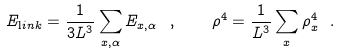Convert formula to latex. <formula><loc_0><loc_0><loc_500><loc_500>E _ { \mathrm l i n k } = \frac { 1 } { 3 L ^ { 3 } } \sum _ { x , \alpha } E _ { x , \alpha } \ , \quad \rho ^ { 4 } = \frac { 1 } { L ^ { 3 } } \sum _ { x } \rho _ { x } ^ { 4 } \ .</formula> 